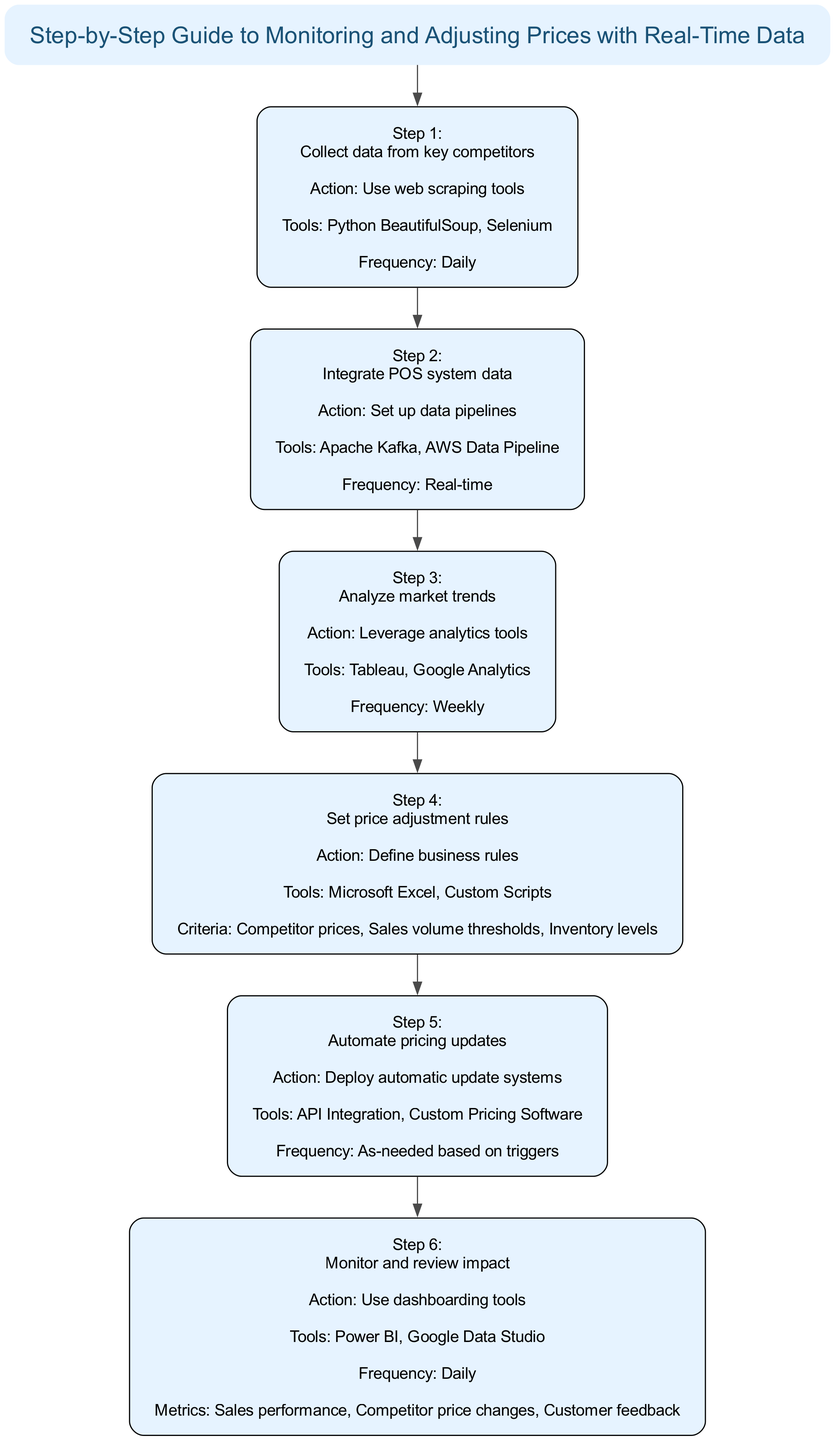What is the title of the diagram? The title is prominently displayed at the top of the diagram, stated in a separate node labeled as "title".
Answer: Step-by-Step Guide to Monitoring and Adjusting Prices with Real-Time Data How many steps are there in the flowchart? By counting each numbered step in the sequence starting from step 1 to step 6, we can determine the total number of steps presented in the diagram.
Answer: 6 What action is taken in step 3? Step 3 describes the action related to analyzing market trends, which can be found in the details of the third step node.
Answer: Leverage analytics tools Which tools are listed under step 2? Step 2's details reference specific tools necessary for integrating the POS system data, which are displayed in the step's node.
Answer: Apache Kafka, AWS Data Pipeline What frequency is mentioned in step 5? The frequency detail in step 5 indicates how often the pricing updates should occur, which is specified in the details section of that step.
Answer: As-needed based on triggers What is the last action taken in the flowchart? Looking at the final step in the sequence (step 6), we can find the action described in that node, which is the last action in the flow of steps.
Answer: Use dashboarding tools In which step is customer purchasing behavior analyzed? The analysis of customer purchasing behavior occurs in step 3, as indicated by the description of that step and its focus on market trends analysis.
Answer: Step 3 Which criteria are considered in step 4 for price adjustment? The criteria for setting price adjustment rules are explicitly mentioned in the details for step 4, encompassing several specific aspects mentioned in the diagram.
Answer: Competitor prices, Sales volume thresholds, Inventory levels What is the purpose of step 1? The purpose of step 1 is identified by its description which focuses on collecting data essential for competitive analysis; this is included in the introductory details of that step.
Answer: Collect data from key competitors 